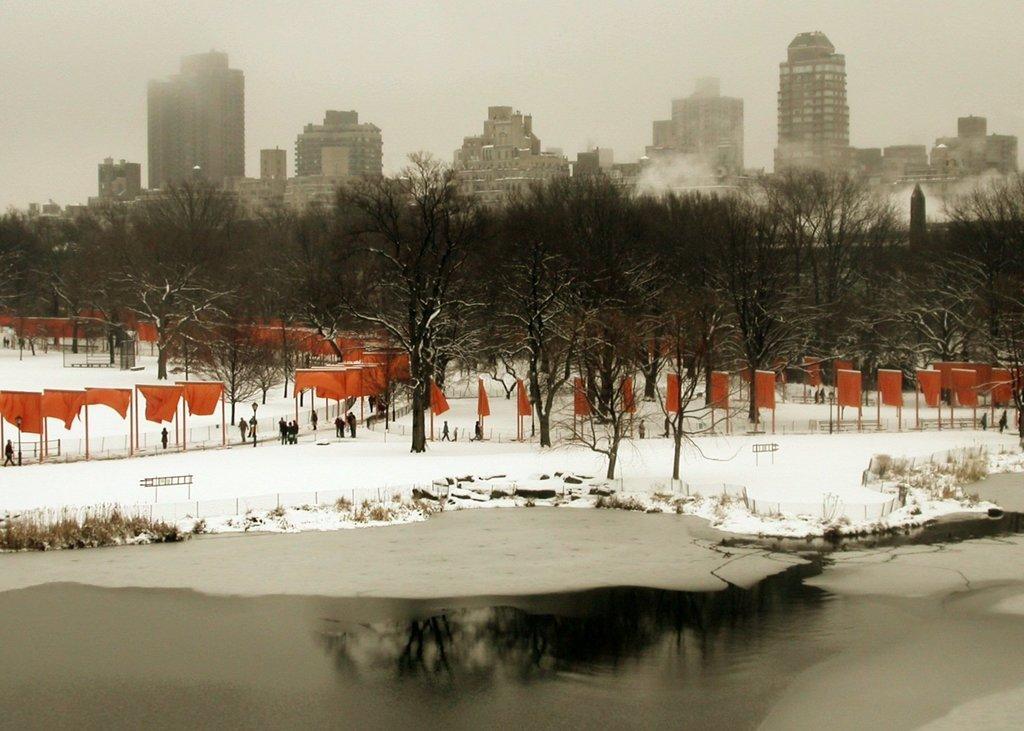Please provide a concise description of this image. As we can see in the image, in the front there are trees, some persons walking and standing, water and the road is covered with snow. In the background there are buildings. On the top there is sky. 